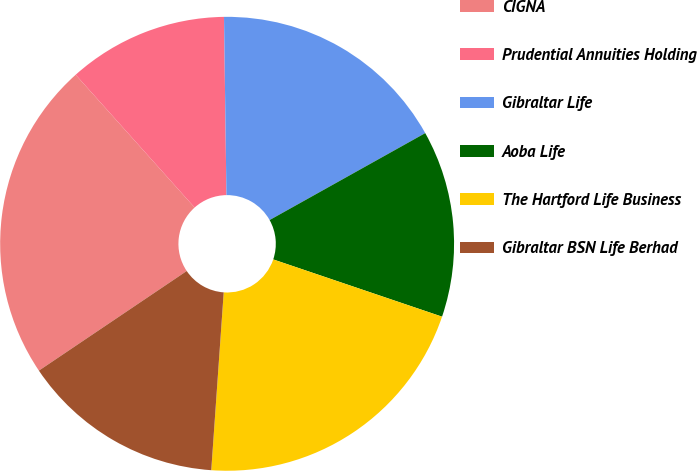Convert chart. <chart><loc_0><loc_0><loc_500><loc_500><pie_chart><fcel>CIGNA<fcel>Prudential Annuities Holding<fcel>Gibraltar Life<fcel>Aoba Life<fcel>The Hartford Life Business<fcel>Gibraltar BSN Life Berhad<nl><fcel>22.81%<fcel>11.41%<fcel>17.11%<fcel>13.31%<fcel>20.91%<fcel>14.45%<nl></chart> 